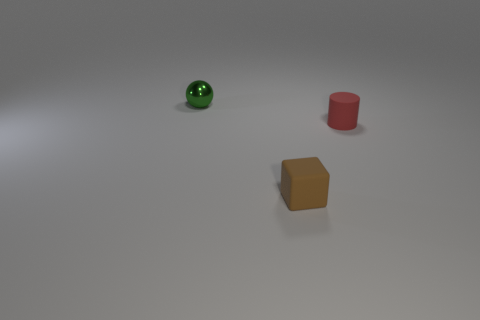Add 2 small green metal balls. How many objects exist? 5 Subtract all balls. How many objects are left? 2 Add 1 small cylinders. How many small cylinders are left? 2 Add 2 tiny red matte cylinders. How many tiny red matte cylinders exist? 3 Subtract 1 brown blocks. How many objects are left? 2 Subtract all matte things. Subtract all small cylinders. How many objects are left? 0 